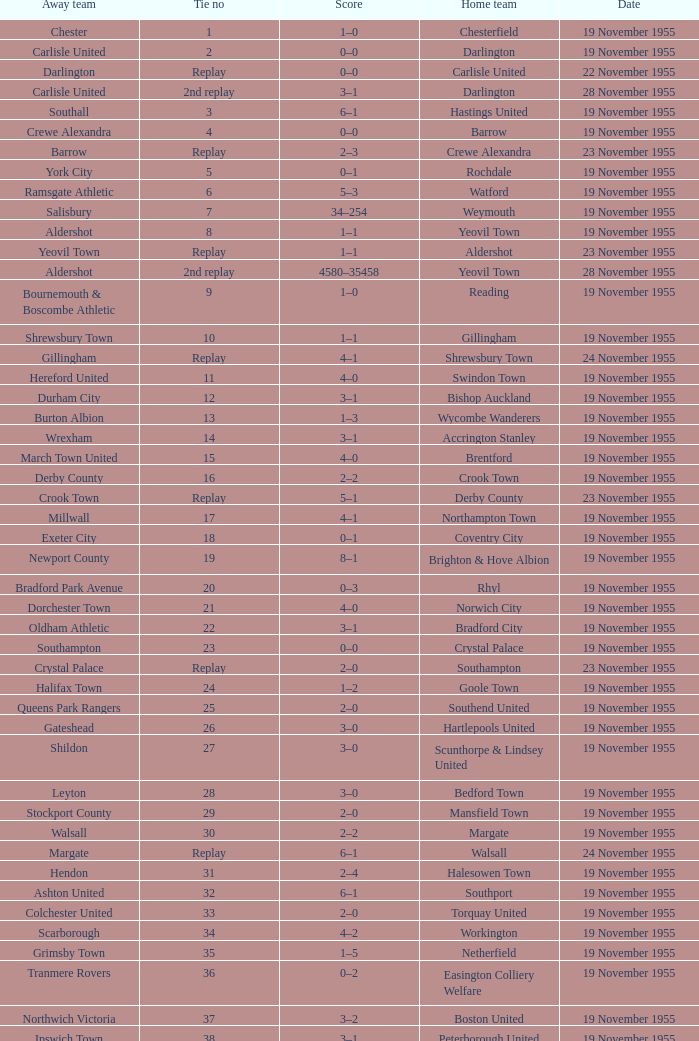What is the away team with a 5 tie no? York City. 